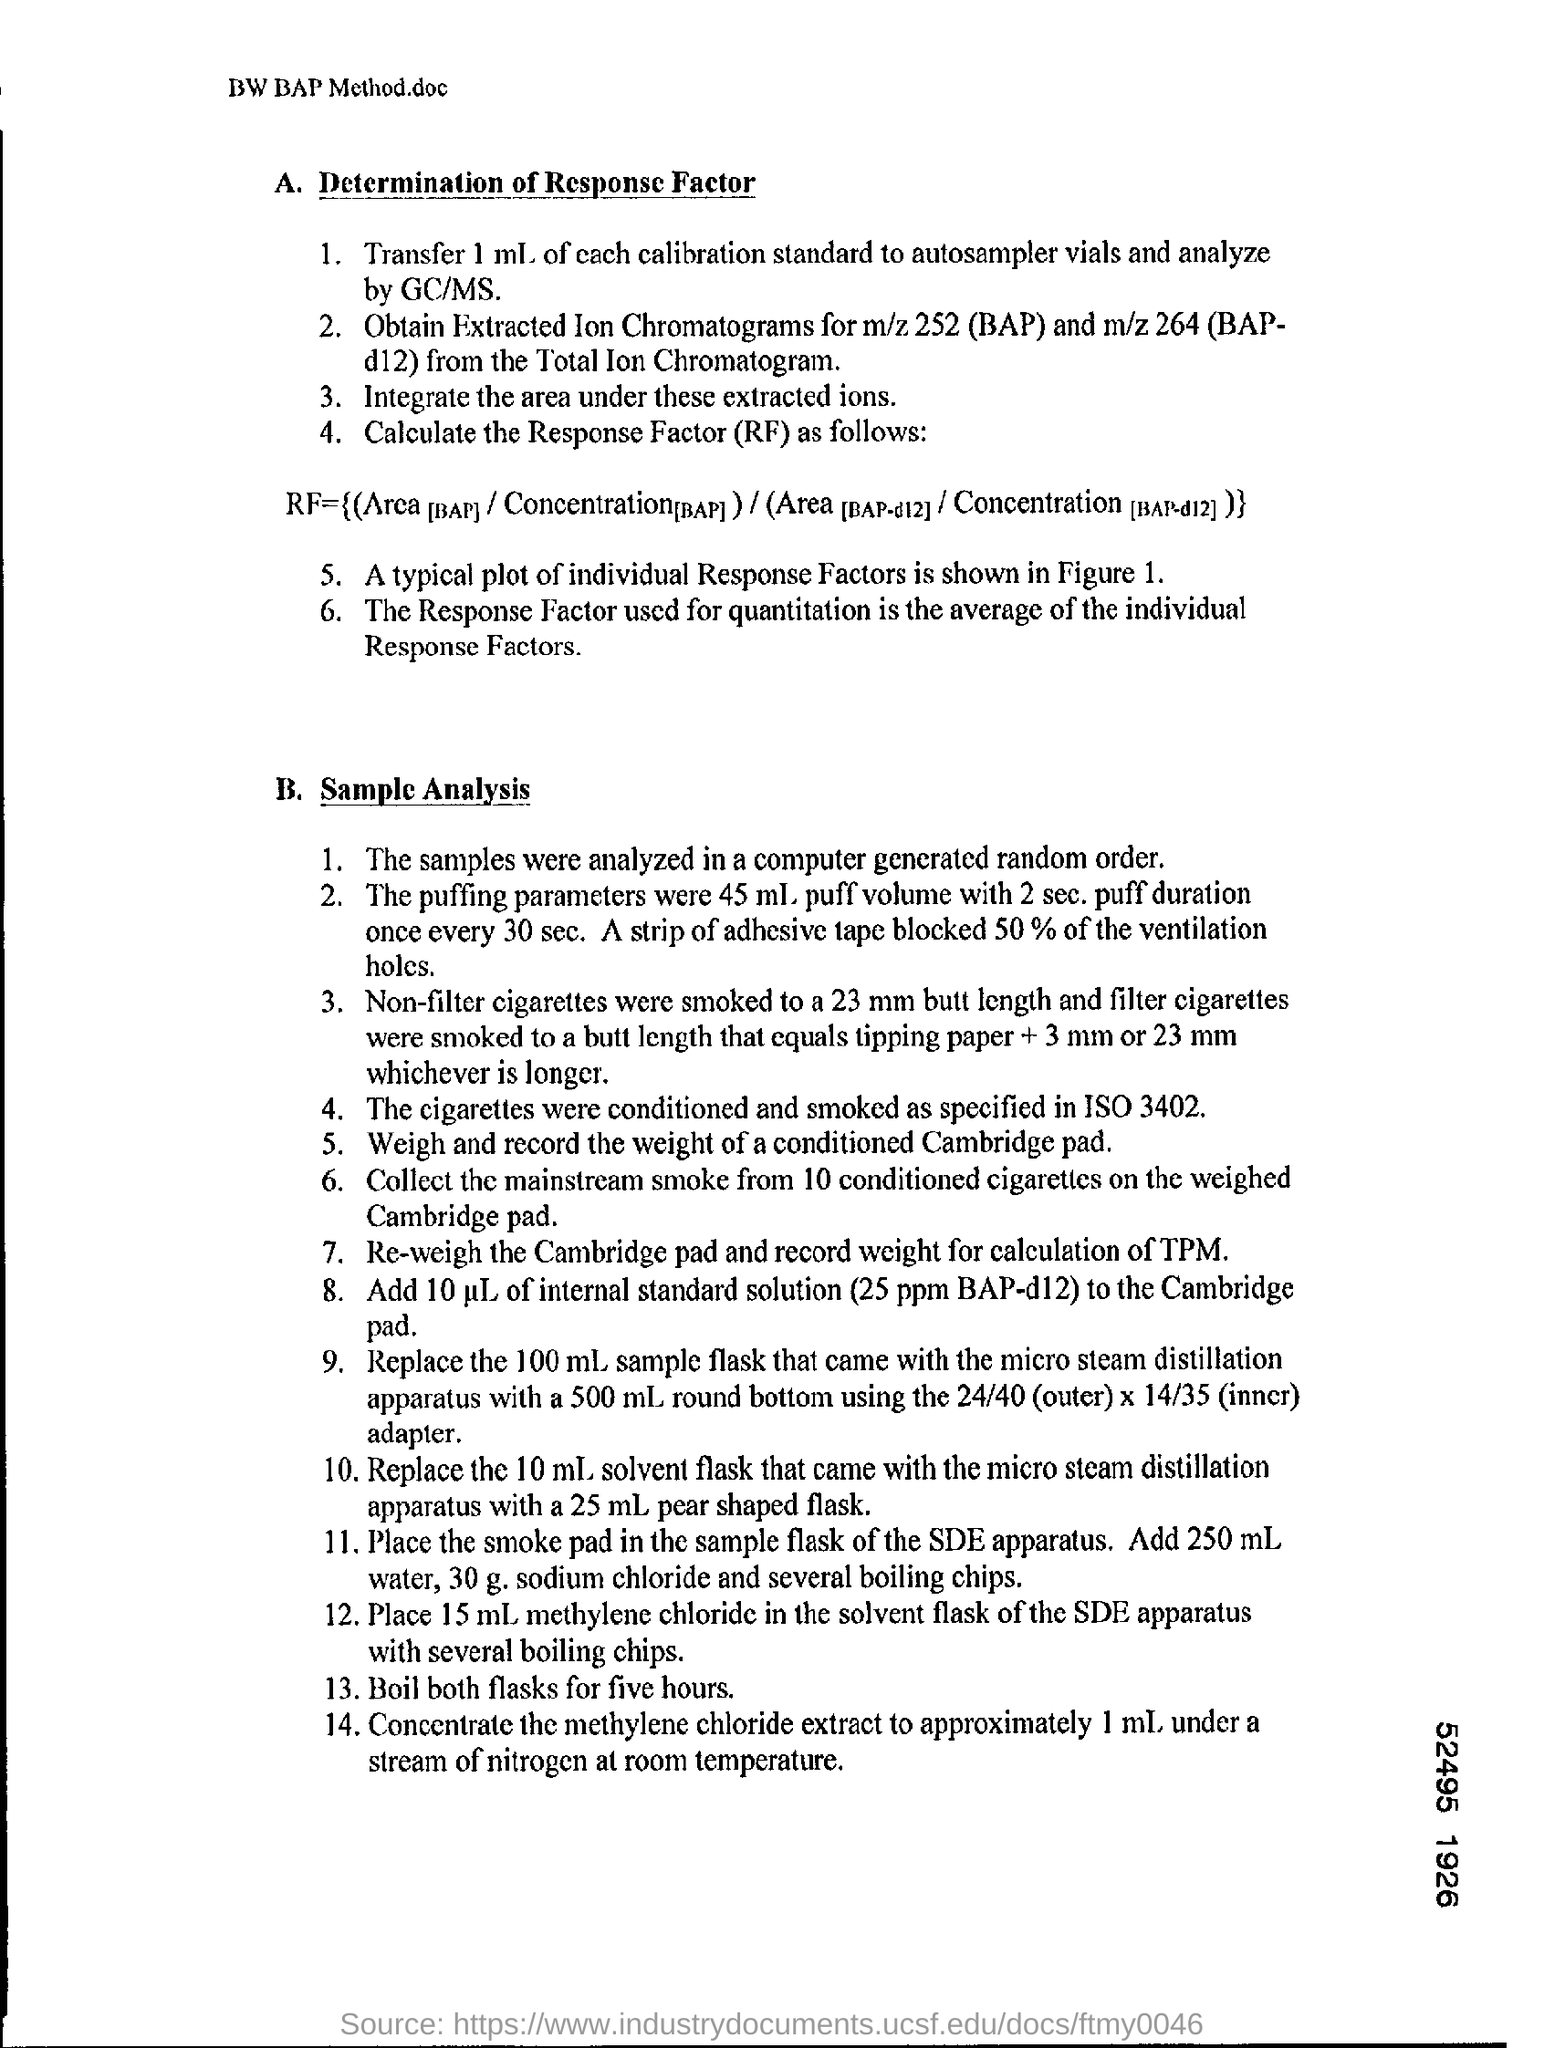In which order the samples were analayzed?
Provide a succinct answer. Computer generated random order. What is the Response Factor used for quantitation?
Offer a very short reply. Is the average of the individual response factors. Depending on what specification, the cigarettes were conditioned and smoked?
Ensure brevity in your answer.  ISO 3402. How much percent of ventilation holes are blocked by a strip of adhesive tape?
Provide a succinct answer. 50 % of the ventilation holes. 